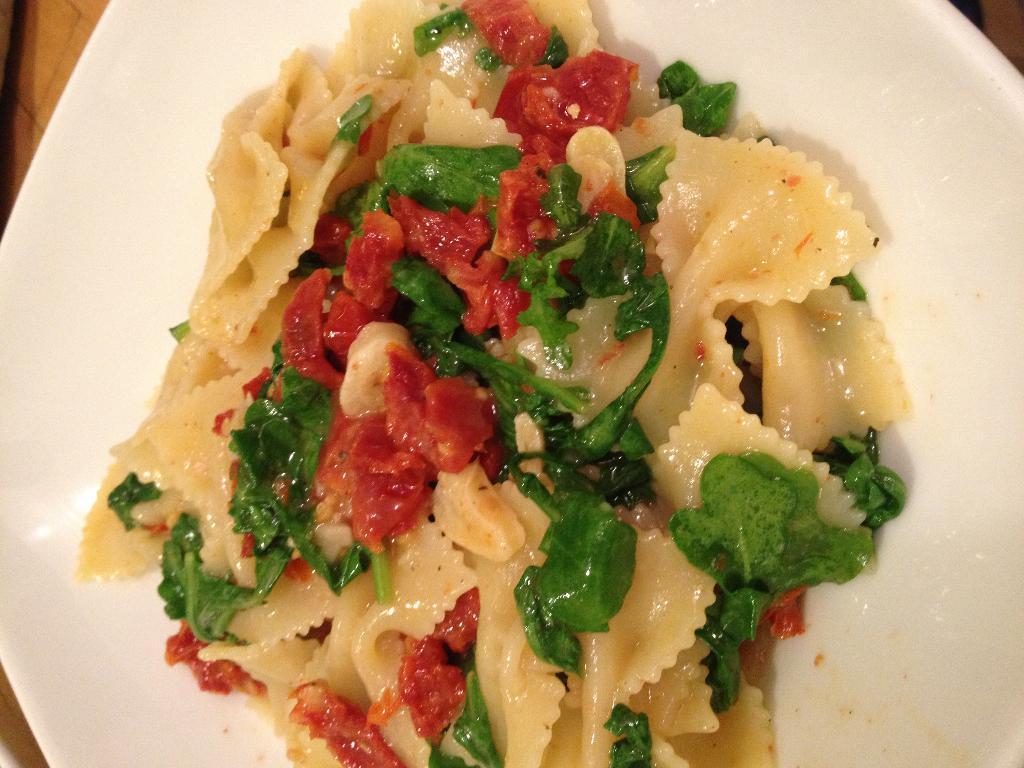How would you summarize this image in a sentence or two? In this image I can see a food item is on the white color plate. Food is in red,green and cream color. 